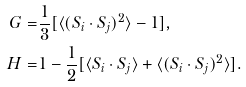<formula> <loc_0><loc_0><loc_500><loc_500>G = & \frac { 1 } 3 [ \langle ( { S } _ { i } \cdot { S } _ { j } ) ^ { 2 } \rangle - 1 ] , \\ H = & 1 - \frac { 1 } 2 [ \langle { S } _ { i } \cdot { S } _ { j } \rangle + \langle ( { S } _ { i } \cdot { S } _ { j } ) ^ { 2 } \rangle ] .</formula> 